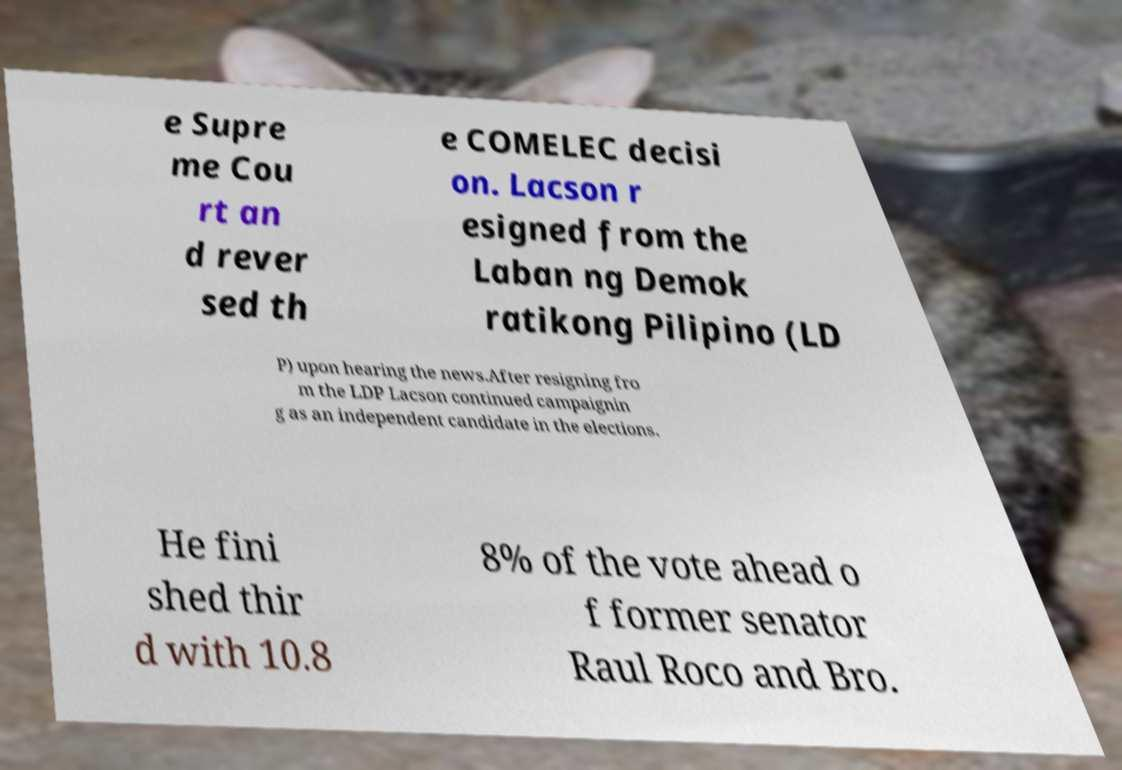Could you assist in decoding the text presented in this image and type it out clearly? e Supre me Cou rt an d rever sed th e COMELEC decisi on. Lacson r esigned from the Laban ng Demok ratikong Pilipino (LD P) upon hearing the news.After resigning fro m the LDP Lacson continued campaignin g as an independent candidate in the elections. He fini shed thir d with 10.8 8% of the vote ahead o f former senator Raul Roco and Bro. 